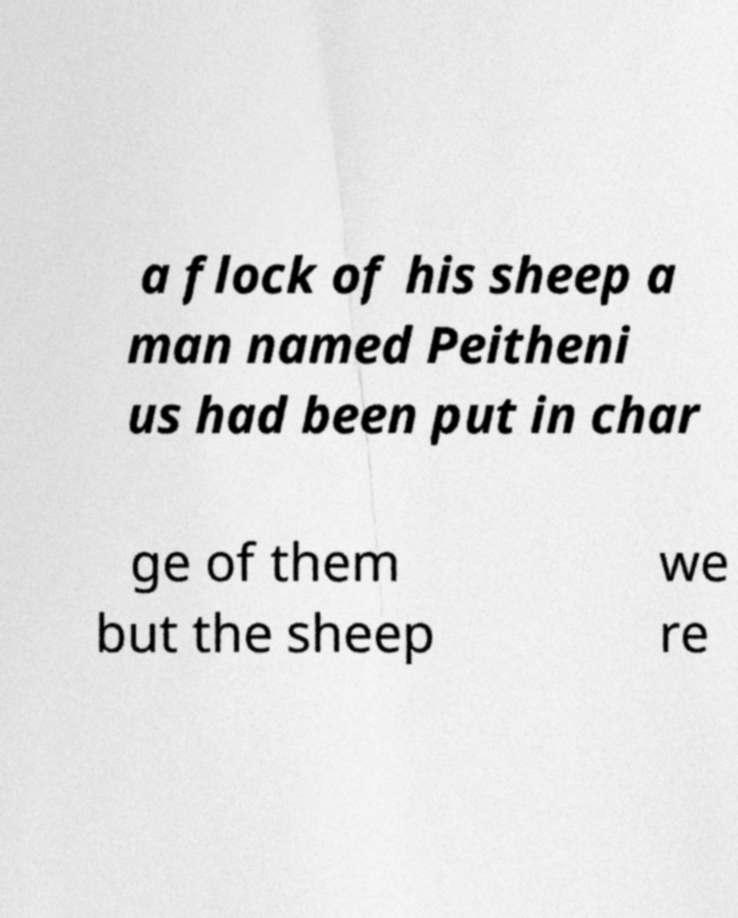For documentation purposes, I need the text within this image transcribed. Could you provide that? a flock of his sheep a man named Peitheni us had been put in char ge of them but the sheep we re 